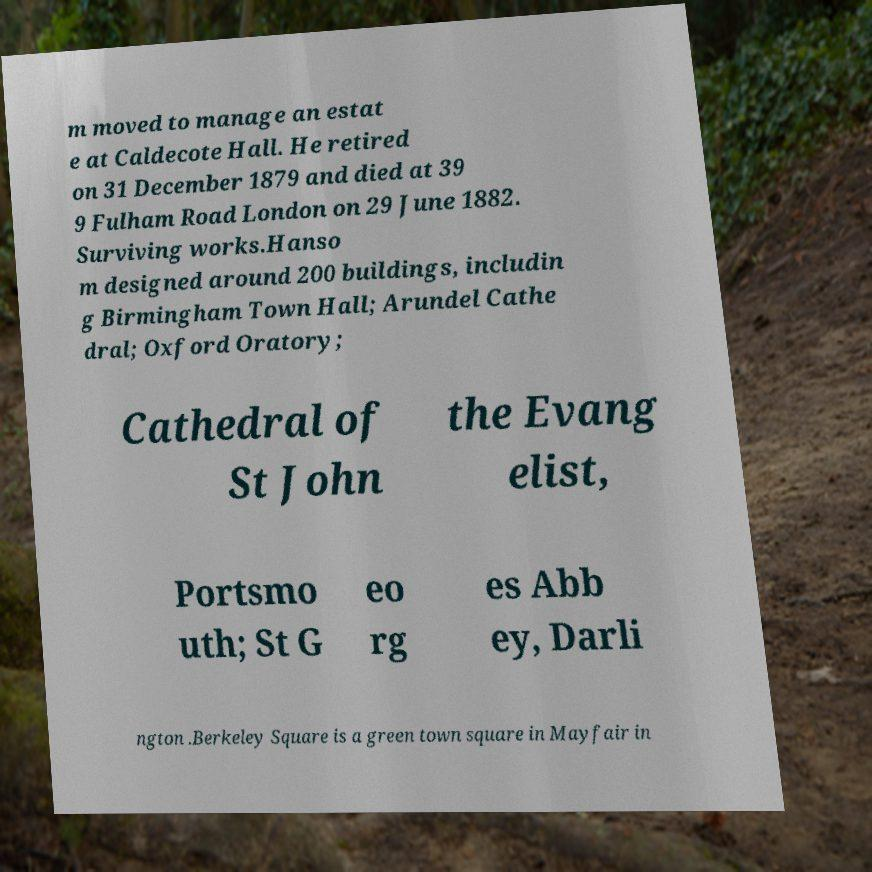Please read and relay the text visible in this image. What does it say? m moved to manage an estat e at Caldecote Hall. He retired on 31 December 1879 and died at 39 9 Fulham Road London on 29 June 1882. Surviving works.Hanso m designed around 200 buildings, includin g Birmingham Town Hall; Arundel Cathe dral; Oxford Oratory; Cathedral of St John the Evang elist, Portsmo uth; St G eo rg es Abb ey, Darli ngton .Berkeley Square is a green town square in Mayfair in 